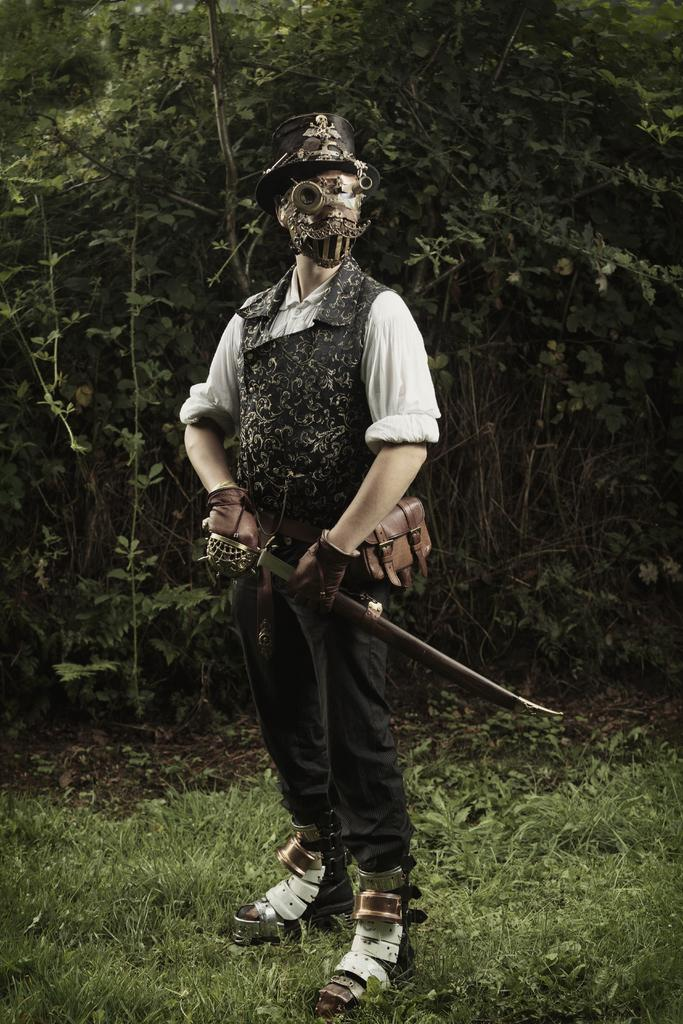What is the main subject of the image? There is a person in the image. What is the person doing in the image? The person is standing. What is the person wearing on their face in the image? The person is wearing a mask. What is the person wearing on their head in the image? The person is wearing a cap. What is the person holding in the image? The person is holding a sword. What type of vegetation can be seen in the background of the image? There are trees in the background of the image. What type of ground is visible at the bottom of the image? There is grass at the bottom of the image. Is the person's brother visible in the image? There is no mention of a brother in the image, so it cannot be determined if the person's brother is present. Can you describe the cellar in the image? There is no cellar present in the image; it features a person standing with a sword, wearing a mask and cap, in front of trees and grass. 